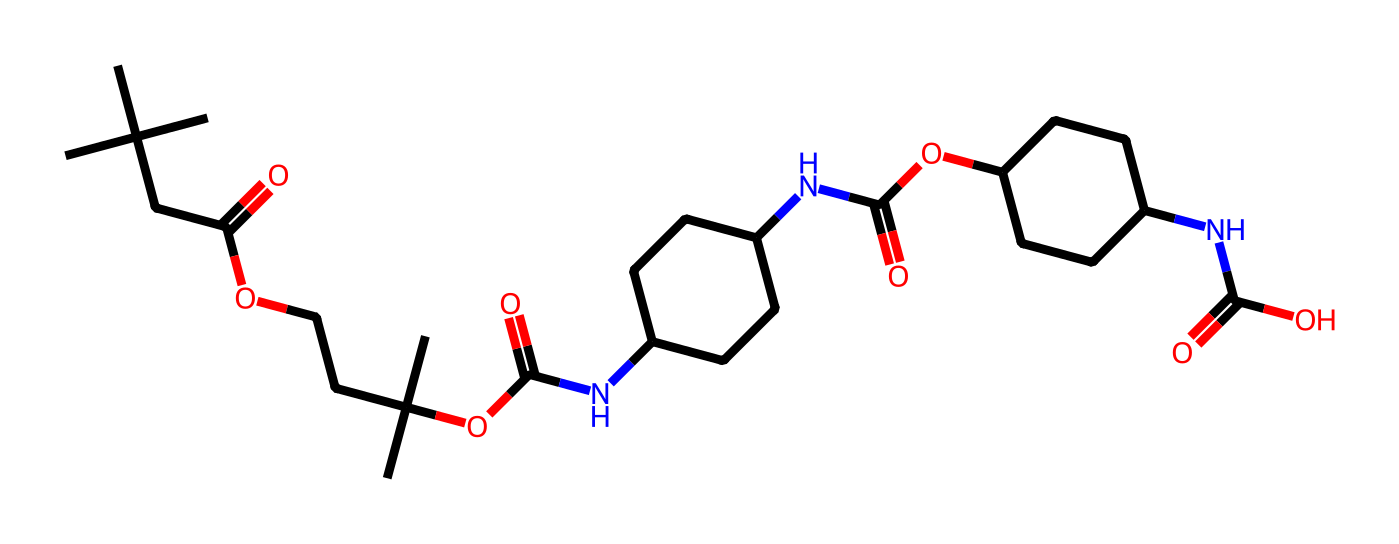what is the functional group at the end of this chemical? The chemical contains an amide functional group, which is identifiable by the presence of a carbonyl group (C=O) adjacent to a nitrogen atom (N). This occurs in the repeating units of the polymer, where the nitrogen is connected to a hydrocarbon chain.
Answer: amide how many carbon atoms are in this structure? To determine the number of carbon atoms, count all the 'C' symbols in the chemical structure. In this SMILES, there are multiple carbon groups. Adding them yields a total of 24 carbon atoms.
Answer: 24 does this polymer contain any heteroatoms? Yes, it contains heteroatoms. A heteroatom is an atom that is not carbon or hydrogen. In this case, nitrogen (N) and oxygen (O) are present in the structure, indicating the presence of heteroatoms in the polymer.
Answer: yes what type of polymer is represented by this chemical structure? This chemical structure represents a polyurethane, characterized by the presence of repeated urethane linkages (R-NH(CO)O), which are formed from the reaction of diisocyanates with polyols. The presence of amide bonds further confirms its classification as a polyurethane.
Answer: polyurethane how does the presence of urethane linkages affect the properties of this polymer? Urethane linkages contribute to the flexibility and durability of the polymer. These linkages create a dense network of bonds that account for the elasticity and impact resistance commonly found in polyurethanes, making them suitable for applications such as surfboards.
Answer: flexibility and durability how many amide bonds are present in the structure? To find out how many amide bonds are present, look for the repeating units identifiable by the N-C(=O) pattern. In the provided SMILES, there are 3 amide bonds that can be observed, indicating multiple connections.
Answer: 3 